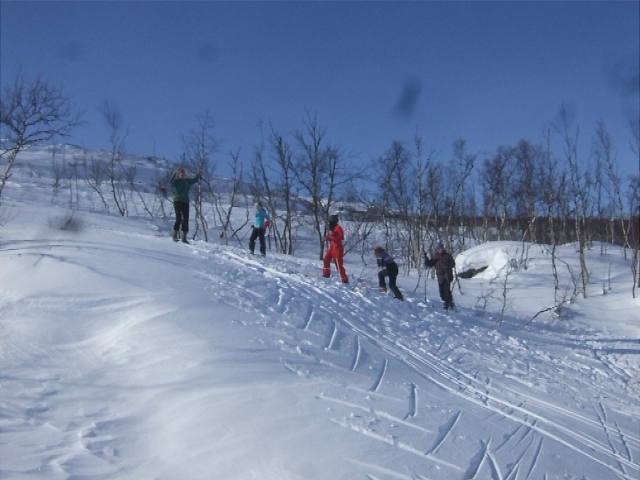Who is the man in red trying to reach?
Choose the right answer and clarify with the format: 'Answer: answer
Rationale: rationale.'
Options: Green jacket, red pants, grey jacket, pink jacket. Answer: green jacket.
Rationale: The skier in the red jacket is trying to get to the top of the hill where the man in green is about to ski down. 